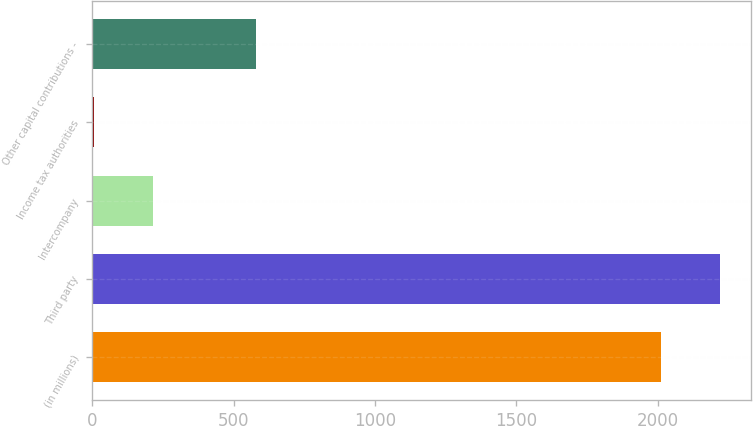<chart> <loc_0><loc_0><loc_500><loc_500><bar_chart><fcel>(in millions)<fcel>Third party<fcel>Intercompany<fcel>Income tax authorities<fcel>Other capital contributions -<nl><fcel>2012<fcel>2220.2<fcel>215.2<fcel>7<fcel>579<nl></chart> 